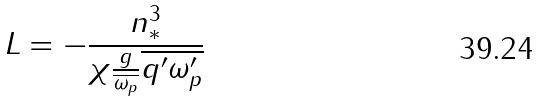<formula> <loc_0><loc_0><loc_500><loc_500>L = - \frac { n _ { * } ^ { 3 } } { \chi \frac { g } { \overline { \omega _ { p } } } \overline { q ^ { \prime } \omega _ { p } ^ { \prime } } }</formula> 